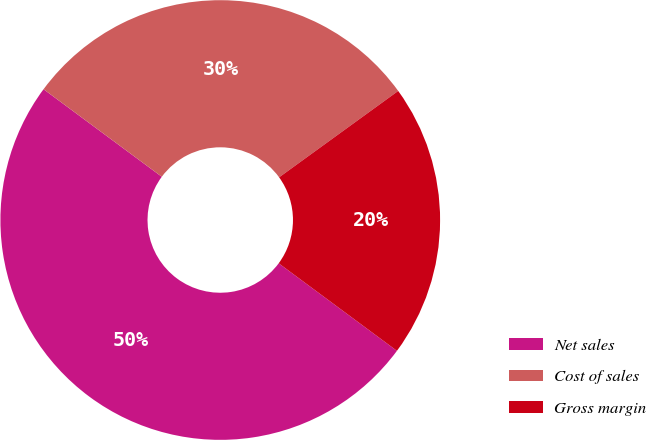<chart> <loc_0><loc_0><loc_500><loc_500><pie_chart><fcel>Net sales<fcel>Cost of sales<fcel>Gross margin<nl><fcel>50.0%<fcel>29.87%<fcel>20.13%<nl></chart> 